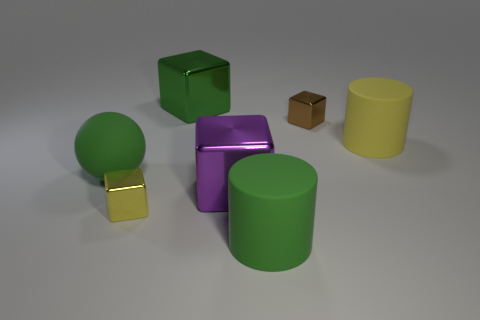Add 1 tiny purple shiny cubes. How many objects exist? 8 Subtract all cylinders. How many objects are left? 5 Subtract 0 gray cylinders. How many objects are left? 7 Subtract all yellow blocks. Subtract all rubber cylinders. How many objects are left? 4 Add 5 large green cubes. How many large green cubes are left? 6 Add 4 large green cylinders. How many large green cylinders exist? 5 